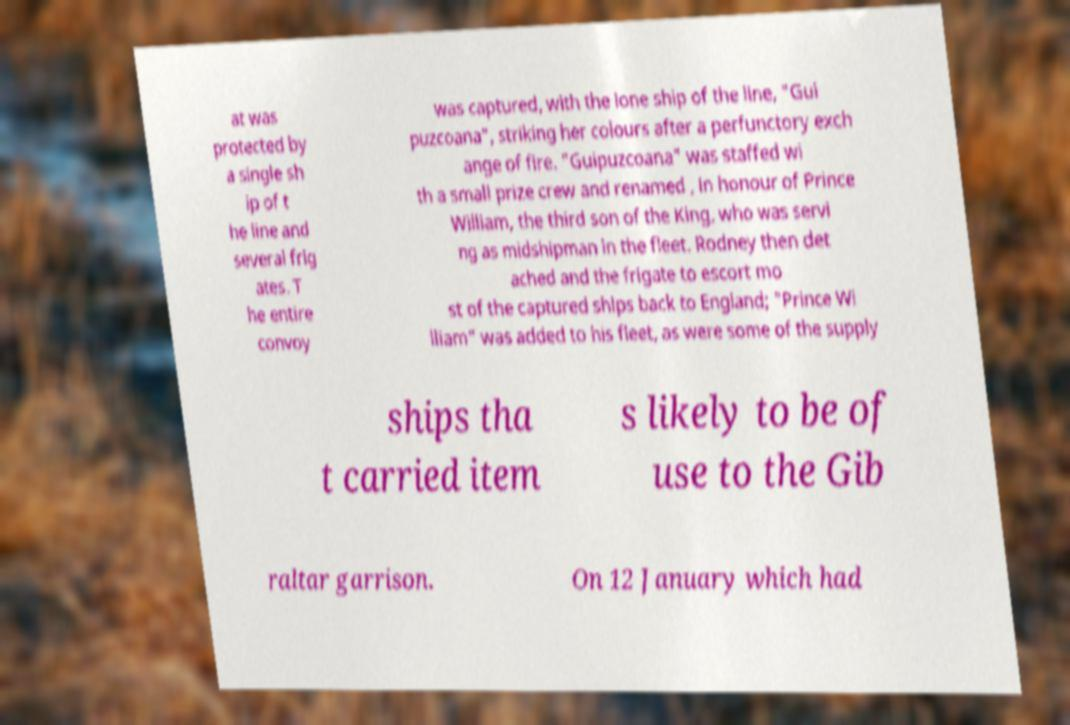I need the written content from this picture converted into text. Can you do that? at was protected by a single sh ip of t he line and several frig ates. T he entire convoy was captured, with the lone ship of the line, "Gui puzcoana", striking her colours after a perfunctory exch ange of fire. "Guipuzcoana" was staffed wi th a small prize crew and renamed , in honour of Prince William, the third son of the King, who was servi ng as midshipman in the fleet. Rodney then det ached and the frigate to escort mo st of the captured ships back to England; "Prince Wi lliam" was added to his fleet, as were some of the supply ships tha t carried item s likely to be of use to the Gib raltar garrison. On 12 January which had 